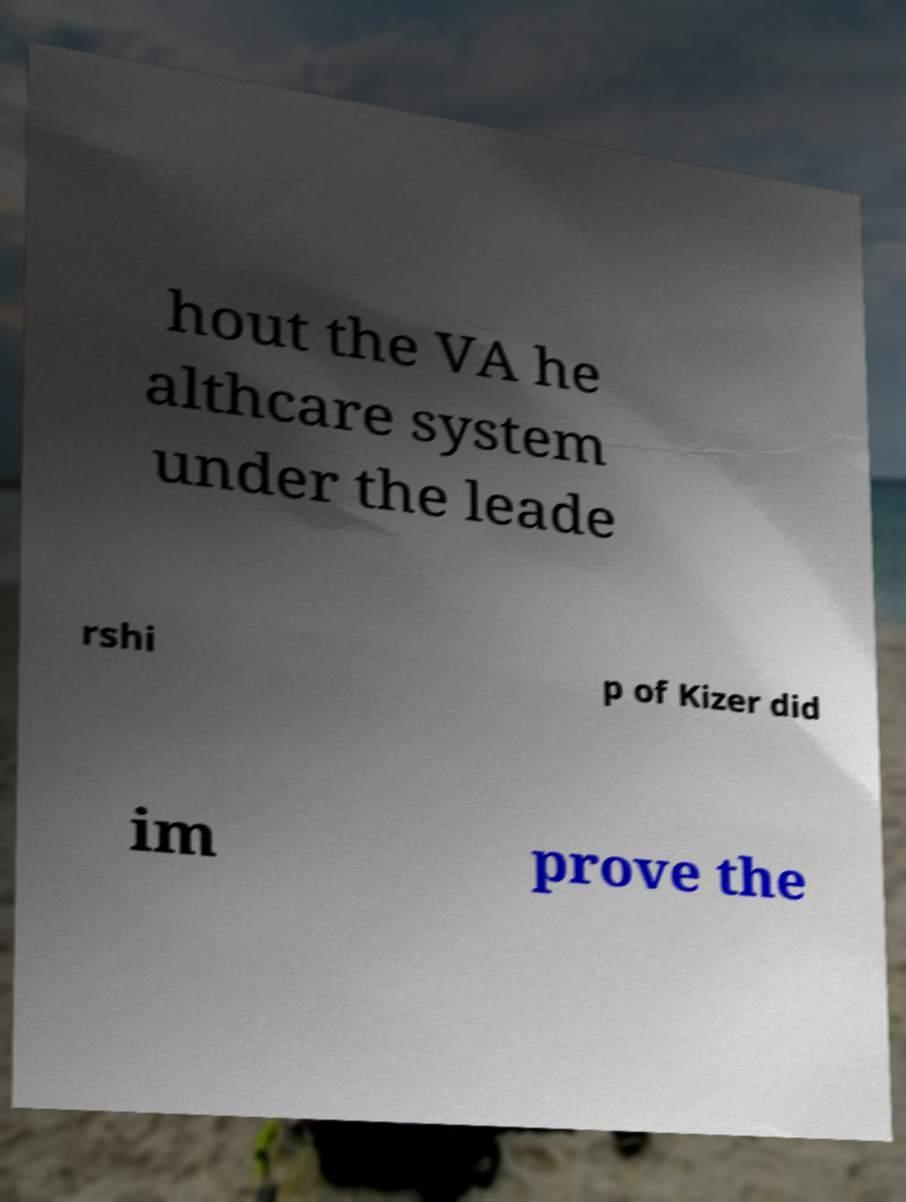Please identify and transcribe the text found in this image. hout the VA he althcare system under the leade rshi p of Kizer did im prove the 